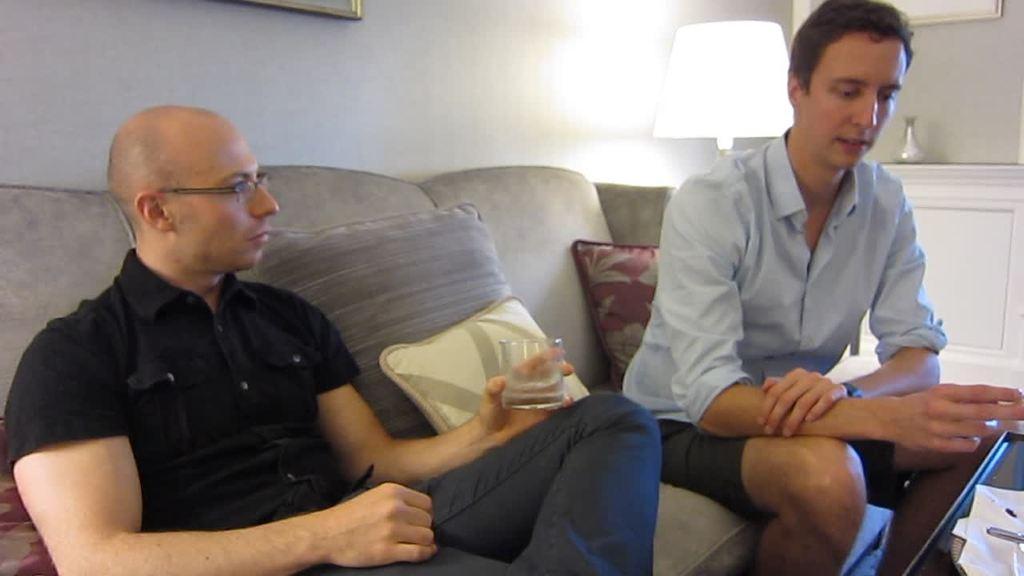Please provide a concise description of this image. In this image I can see two people sitting on the couch and wearing the different color dresses. I can see one person is holding the glass. To the side I can see the pillows. In-front of these people I can see the teapoy and some objects on it. In the background I can see the lamp and the vase on the table. I can also see the frames to the wall. 